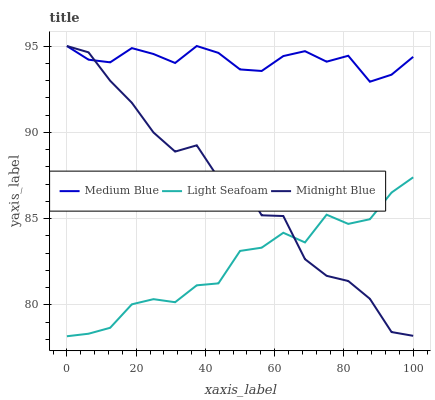Does Light Seafoam have the minimum area under the curve?
Answer yes or no. Yes. Does Medium Blue have the maximum area under the curve?
Answer yes or no. Yes. Does Midnight Blue have the minimum area under the curve?
Answer yes or no. No. Does Midnight Blue have the maximum area under the curve?
Answer yes or no. No. Is Medium Blue the smoothest?
Answer yes or no. Yes. Is Midnight Blue the roughest?
Answer yes or no. Yes. Is Midnight Blue the smoothest?
Answer yes or no. No. Is Medium Blue the roughest?
Answer yes or no. No. Does Midnight Blue have the lowest value?
Answer yes or no. No. Does Midnight Blue have the highest value?
Answer yes or no. Yes. Is Light Seafoam less than Medium Blue?
Answer yes or no. Yes. Is Medium Blue greater than Light Seafoam?
Answer yes or no. Yes. Does Light Seafoam intersect Medium Blue?
Answer yes or no. No. 